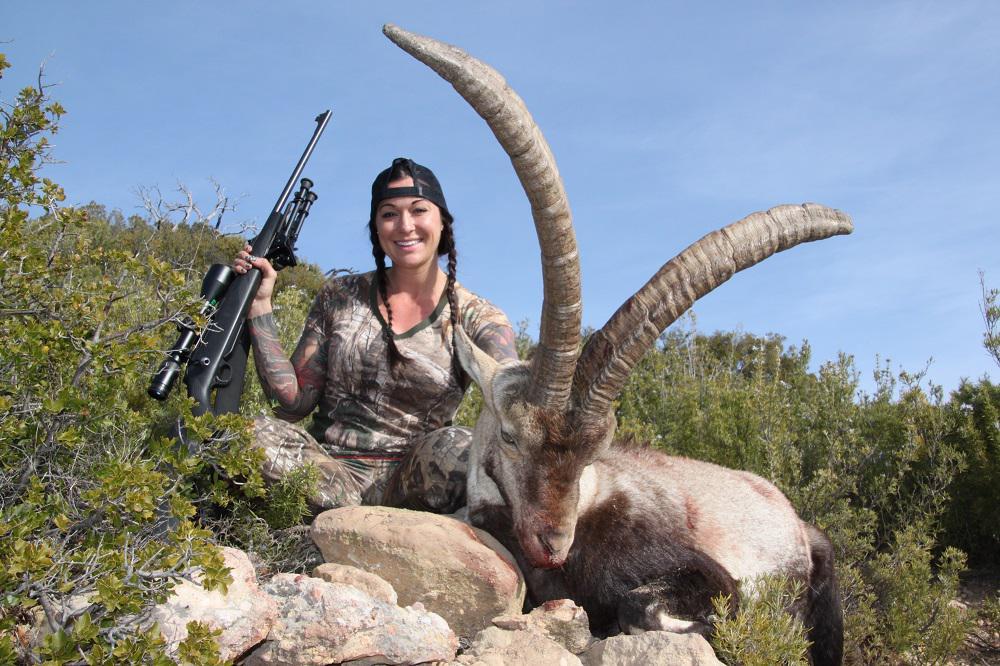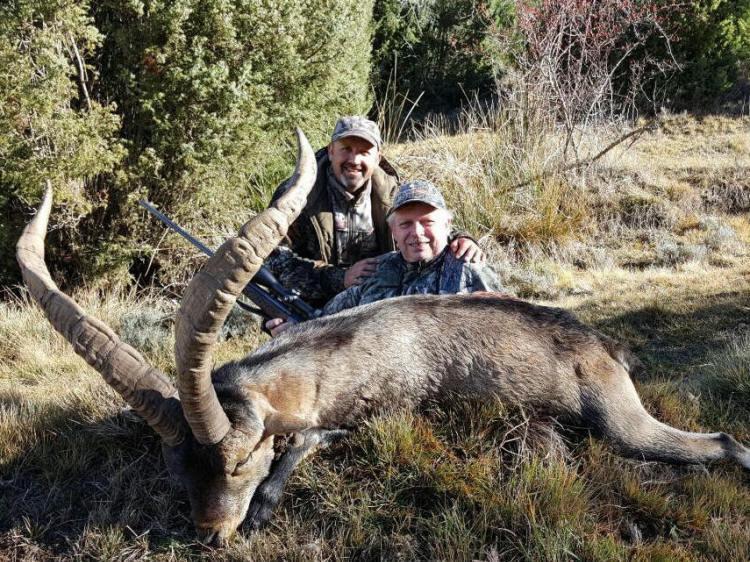The first image is the image on the left, the second image is the image on the right. Given the left and right images, does the statement "The left and right image contains a total of  two goats with at least two hunters." hold true? Answer yes or no. Yes. The first image is the image on the left, the second image is the image on the right. Analyze the images presented: Is the assertion "The left picture does not have a human in it." valid? Answer yes or no. No. 